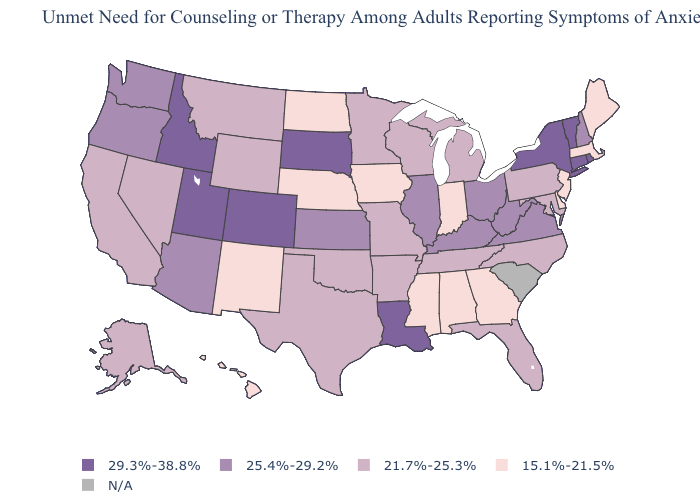Among the states that border South Dakota , which have the lowest value?
Concise answer only. Iowa, Nebraska, North Dakota. Among the states that border Mississippi , which have the highest value?
Keep it brief. Louisiana. Does Colorado have the highest value in the USA?
Concise answer only. Yes. What is the value of Pennsylvania?
Be succinct. 21.7%-25.3%. What is the highest value in the Northeast ?
Answer briefly. 29.3%-38.8%. Does Oklahoma have the highest value in the USA?
Write a very short answer. No. What is the value of New Mexico?
Be succinct. 15.1%-21.5%. What is the lowest value in the MidWest?
Keep it brief. 15.1%-21.5%. What is the value of Nevada?
Concise answer only. 21.7%-25.3%. What is the value of Arizona?
Answer briefly. 25.4%-29.2%. How many symbols are there in the legend?
Short answer required. 5. How many symbols are there in the legend?
Quick response, please. 5. Does Connecticut have the lowest value in the Northeast?
Write a very short answer. No. Among the states that border North Dakota , which have the lowest value?
Write a very short answer. Minnesota, Montana. Name the states that have a value in the range 21.7%-25.3%?
Quick response, please. Alaska, Arkansas, California, Florida, Maryland, Michigan, Minnesota, Missouri, Montana, Nevada, North Carolina, Oklahoma, Pennsylvania, Tennessee, Texas, Wisconsin, Wyoming. 